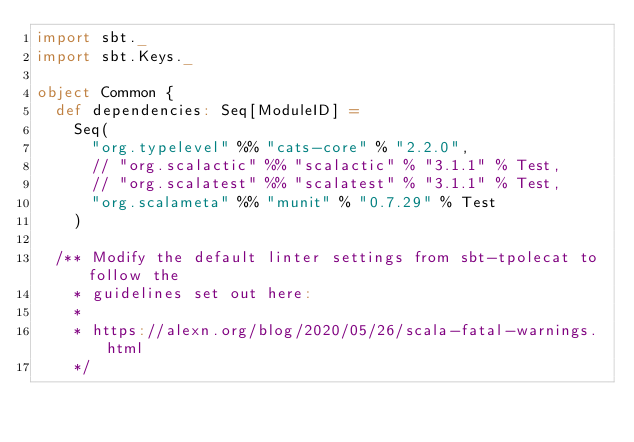<code> <loc_0><loc_0><loc_500><loc_500><_Scala_>import sbt._
import sbt.Keys._

object Common {
  def dependencies: Seq[ModuleID] =
    Seq(
      "org.typelevel" %% "cats-core" % "2.2.0",
      // "org.scalactic" %% "scalactic" % "3.1.1" % Test,
      // "org.scalatest" %% "scalatest" % "3.1.1" % Test,
      "org.scalameta" %% "munit" % "0.7.29" % Test
    )

  /** Modify the default linter settings from sbt-tpolecat to follow the
    * guidelines set out here:
    *
    * https://alexn.org/blog/2020/05/26/scala-fatal-warnings.html
    */</code> 